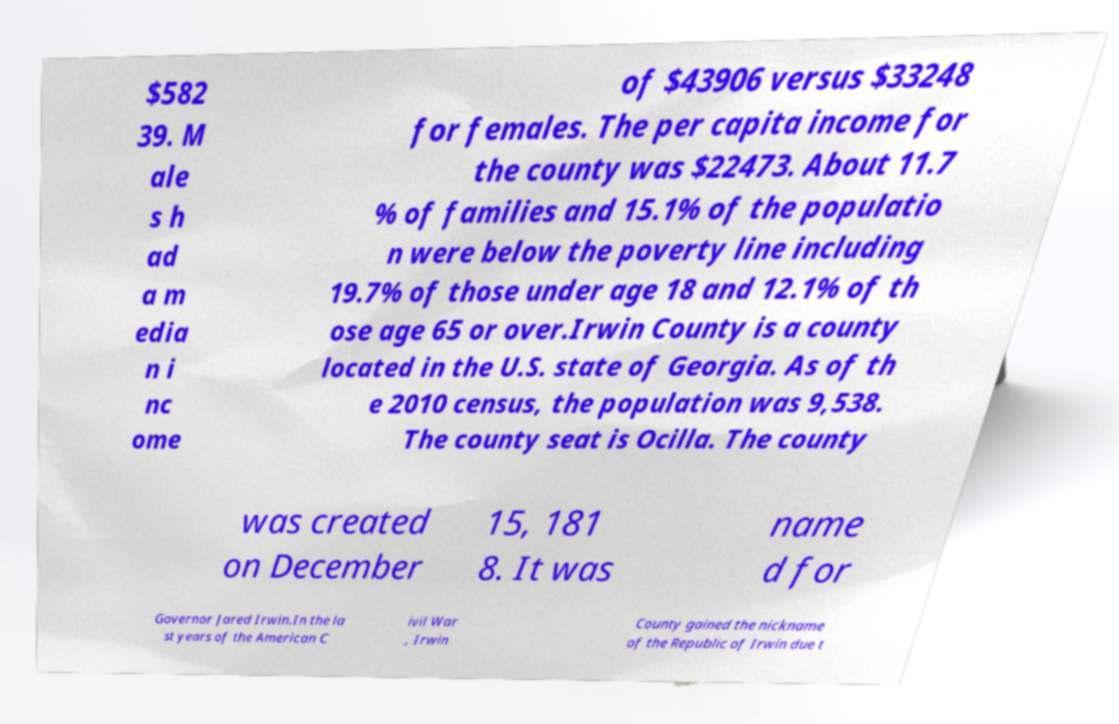Can you read and provide the text displayed in the image?This photo seems to have some interesting text. Can you extract and type it out for me? $582 39. M ale s h ad a m edia n i nc ome of $43906 versus $33248 for females. The per capita income for the county was $22473. About 11.7 % of families and 15.1% of the populatio n were below the poverty line including 19.7% of those under age 18 and 12.1% of th ose age 65 or over.Irwin County is a county located in the U.S. state of Georgia. As of th e 2010 census, the population was 9,538. The county seat is Ocilla. The county was created on December 15, 181 8. It was name d for Governor Jared Irwin.In the la st years of the American C ivil War , Irwin County gained the nickname of the Republic of Irwin due t 